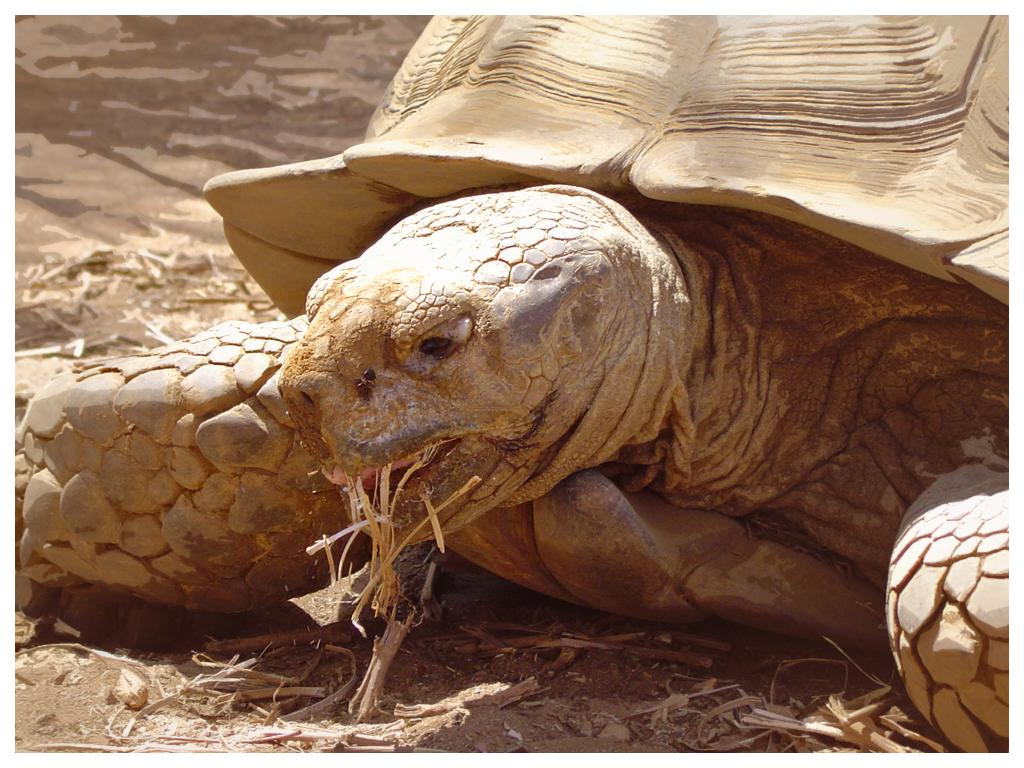What type of animal is in the image? There is a tortoise in the image. What time of day does the image appear to be taken? The image appears to be taken during the day. Can you describe the environment in the image? The image may have been taken near a sandy beach. What type of ink is being used by the snake in the image? There is no snake present in the image, and therefore no ink or action involving ink can be observed. 